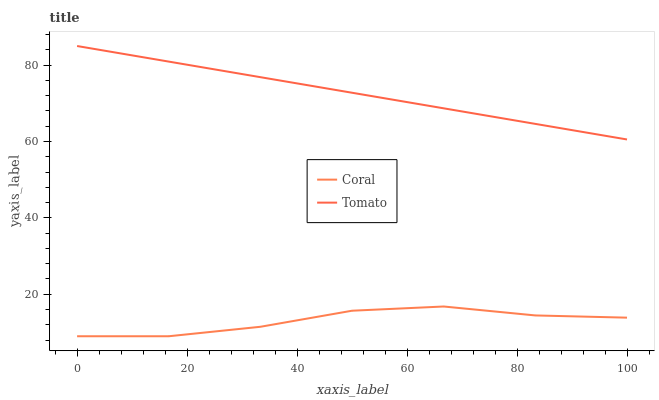Does Coral have the minimum area under the curve?
Answer yes or no. Yes. Does Tomato have the maximum area under the curve?
Answer yes or no. Yes. Does Coral have the maximum area under the curve?
Answer yes or no. No. Is Tomato the smoothest?
Answer yes or no. Yes. Is Coral the roughest?
Answer yes or no. Yes. Is Coral the smoothest?
Answer yes or no. No. Does Coral have the lowest value?
Answer yes or no. Yes. Does Tomato have the highest value?
Answer yes or no. Yes. Does Coral have the highest value?
Answer yes or no. No. Is Coral less than Tomato?
Answer yes or no. Yes. Is Tomato greater than Coral?
Answer yes or no. Yes. Does Coral intersect Tomato?
Answer yes or no. No. 